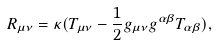Convert formula to latex. <formula><loc_0><loc_0><loc_500><loc_500>R _ { \mu \nu } = \kappa ( T _ { \mu \nu } - \frac { 1 } { 2 } g _ { \mu \nu } g ^ { \alpha \beta } T _ { \alpha \beta } ) ,</formula> 